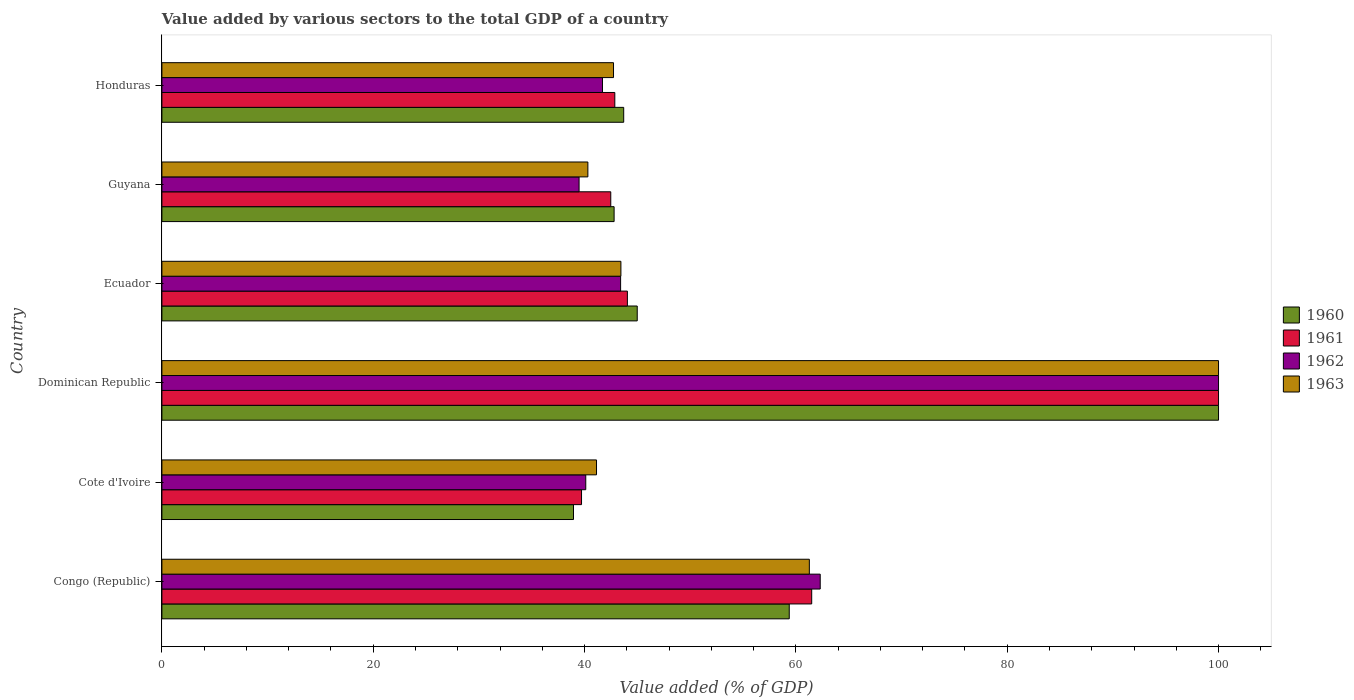Are the number of bars on each tick of the Y-axis equal?
Give a very brief answer. Yes. What is the label of the 4th group of bars from the top?
Provide a short and direct response. Dominican Republic. In how many cases, is the number of bars for a given country not equal to the number of legend labels?
Provide a succinct answer. 0. What is the value added by various sectors to the total GDP in 1963 in Congo (Republic)?
Offer a terse response. 61.27. Across all countries, what is the maximum value added by various sectors to the total GDP in 1960?
Your answer should be very brief. 100. Across all countries, what is the minimum value added by various sectors to the total GDP in 1963?
Your answer should be compact. 40.31. In which country was the value added by various sectors to the total GDP in 1963 maximum?
Keep it short and to the point. Dominican Republic. In which country was the value added by various sectors to the total GDP in 1961 minimum?
Provide a succinct answer. Cote d'Ivoire. What is the total value added by various sectors to the total GDP in 1962 in the graph?
Offer a very short reply. 327.01. What is the difference between the value added by various sectors to the total GDP in 1961 in Congo (Republic) and that in Guyana?
Give a very brief answer. 19.02. What is the difference between the value added by various sectors to the total GDP in 1962 in Dominican Republic and the value added by various sectors to the total GDP in 1960 in Cote d'Ivoire?
Your response must be concise. 61.05. What is the average value added by various sectors to the total GDP in 1960 per country?
Ensure brevity in your answer.  54.97. What is the difference between the value added by various sectors to the total GDP in 1961 and value added by various sectors to the total GDP in 1963 in Congo (Republic)?
Your answer should be compact. 0.22. What is the ratio of the value added by various sectors to the total GDP in 1962 in Congo (Republic) to that in Guyana?
Give a very brief answer. 1.58. Is the value added by various sectors to the total GDP in 1960 in Cote d'Ivoire less than that in Guyana?
Offer a terse response. Yes. What is the difference between the highest and the second highest value added by various sectors to the total GDP in 1963?
Offer a terse response. 38.73. What is the difference between the highest and the lowest value added by various sectors to the total GDP in 1963?
Provide a short and direct response. 59.69. Is the sum of the value added by various sectors to the total GDP in 1960 in Dominican Republic and Honduras greater than the maximum value added by various sectors to the total GDP in 1961 across all countries?
Keep it short and to the point. Yes. Is it the case that in every country, the sum of the value added by various sectors to the total GDP in 1960 and value added by various sectors to the total GDP in 1963 is greater than the sum of value added by various sectors to the total GDP in 1962 and value added by various sectors to the total GDP in 1961?
Offer a terse response. No. What does the 2nd bar from the top in Congo (Republic) represents?
Your answer should be very brief. 1962. How many bars are there?
Give a very brief answer. 24. Are all the bars in the graph horizontal?
Ensure brevity in your answer.  Yes. Are the values on the major ticks of X-axis written in scientific E-notation?
Provide a short and direct response. No. Does the graph contain grids?
Provide a succinct answer. No. How many legend labels are there?
Keep it short and to the point. 4. What is the title of the graph?
Offer a terse response. Value added by various sectors to the total GDP of a country. What is the label or title of the X-axis?
Keep it short and to the point. Value added (% of GDP). What is the Value added (% of GDP) of 1960 in Congo (Republic)?
Your answer should be compact. 59.37. What is the Value added (% of GDP) of 1961 in Congo (Republic)?
Offer a very short reply. 61.5. What is the Value added (% of GDP) of 1962 in Congo (Republic)?
Give a very brief answer. 62.3. What is the Value added (% of GDP) in 1963 in Congo (Republic)?
Keep it short and to the point. 61.27. What is the Value added (% of GDP) in 1960 in Cote d'Ivoire?
Offer a very short reply. 38.95. What is the Value added (% of GDP) in 1961 in Cote d'Ivoire?
Provide a succinct answer. 39.71. What is the Value added (% of GDP) of 1962 in Cote d'Ivoire?
Your response must be concise. 40.11. What is the Value added (% of GDP) in 1963 in Cote d'Ivoire?
Offer a terse response. 41.13. What is the Value added (% of GDP) in 1961 in Dominican Republic?
Your answer should be very brief. 100. What is the Value added (% of GDP) in 1962 in Dominican Republic?
Provide a short and direct response. 100. What is the Value added (% of GDP) in 1960 in Ecuador?
Provide a short and direct response. 44.99. What is the Value added (% of GDP) in 1961 in Ecuador?
Keep it short and to the point. 44.05. What is the Value added (% of GDP) in 1962 in Ecuador?
Ensure brevity in your answer.  43.41. What is the Value added (% of GDP) of 1963 in Ecuador?
Provide a short and direct response. 43.44. What is the Value added (% of GDP) of 1960 in Guyana?
Keep it short and to the point. 42.8. What is the Value added (% of GDP) of 1961 in Guyana?
Keep it short and to the point. 42.48. What is the Value added (% of GDP) in 1962 in Guyana?
Provide a short and direct response. 39.48. What is the Value added (% of GDP) of 1963 in Guyana?
Your answer should be very brief. 40.31. What is the Value added (% of GDP) in 1960 in Honduras?
Provide a short and direct response. 43.7. What is the Value added (% of GDP) in 1961 in Honduras?
Keep it short and to the point. 42.86. What is the Value added (% of GDP) in 1962 in Honduras?
Your response must be concise. 41.7. What is the Value added (% of GDP) in 1963 in Honduras?
Give a very brief answer. 42.74. Across all countries, what is the maximum Value added (% of GDP) in 1963?
Offer a very short reply. 100. Across all countries, what is the minimum Value added (% of GDP) of 1960?
Offer a terse response. 38.95. Across all countries, what is the minimum Value added (% of GDP) of 1961?
Your answer should be very brief. 39.71. Across all countries, what is the minimum Value added (% of GDP) of 1962?
Your response must be concise. 39.48. Across all countries, what is the minimum Value added (% of GDP) in 1963?
Your answer should be very brief. 40.31. What is the total Value added (% of GDP) of 1960 in the graph?
Your answer should be very brief. 329.81. What is the total Value added (% of GDP) in 1961 in the graph?
Ensure brevity in your answer.  330.61. What is the total Value added (% of GDP) of 1962 in the graph?
Offer a very short reply. 327.01. What is the total Value added (% of GDP) of 1963 in the graph?
Provide a succinct answer. 328.9. What is the difference between the Value added (% of GDP) in 1960 in Congo (Republic) and that in Cote d'Ivoire?
Your response must be concise. 20.42. What is the difference between the Value added (% of GDP) of 1961 in Congo (Republic) and that in Cote d'Ivoire?
Your answer should be very brief. 21.78. What is the difference between the Value added (% of GDP) in 1962 in Congo (Republic) and that in Cote d'Ivoire?
Provide a short and direct response. 22.19. What is the difference between the Value added (% of GDP) of 1963 in Congo (Republic) and that in Cote d'Ivoire?
Offer a very short reply. 20.14. What is the difference between the Value added (% of GDP) in 1960 in Congo (Republic) and that in Dominican Republic?
Ensure brevity in your answer.  -40.63. What is the difference between the Value added (% of GDP) of 1961 in Congo (Republic) and that in Dominican Republic?
Your answer should be very brief. -38.5. What is the difference between the Value added (% of GDP) in 1962 in Congo (Republic) and that in Dominican Republic?
Offer a terse response. -37.7. What is the difference between the Value added (% of GDP) of 1963 in Congo (Republic) and that in Dominican Republic?
Offer a very short reply. -38.73. What is the difference between the Value added (% of GDP) of 1960 in Congo (Republic) and that in Ecuador?
Give a very brief answer. 14.39. What is the difference between the Value added (% of GDP) of 1961 in Congo (Republic) and that in Ecuador?
Make the answer very short. 17.44. What is the difference between the Value added (% of GDP) of 1962 in Congo (Republic) and that in Ecuador?
Provide a succinct answer. 18.89. What is the difference between the Value added (% of GDP) in 1963 in Congo (Republic) and that in Ecuador?
Provide a short and direct response. 17.83. What is the difference between the Value added (% of GDP) in 1960 in Congo (Republic) and that in Guyana?
Keep it short and to the point. 16.57. What is the difference between the Value added (% of GDP) of 1961 in Congo (Republic) and that in Guyana?
Offer a very short reply. 19.02. What is the difference between the Value added (% of GDP) in 1962 in Congo (Republic) and that in Guyana?
Offer a very short reply. 22.82. What is the difference between the Value added (% of GDP) in 1963 in Congo (Republic) and that in Guyana?
Provide a succinct answer. 20.96. What is the difference between the Value added (% of GDP) of 1960 in Congo (Republic) and that in Honduras?
Your answer should be very brief. 15.67. What is the difference between the Value added (% of GDP) in 1961 in Congo (Republic) and that in Honduras?
Keep it short and to the point. 18.63. What is the difference between the Value added (% of GDP) in 1962 in Congo (Republic) and that in Honduras?
Your answer should be compact. 20.61. What is the difference between the Value added (% of GDP) of 1963 in Congo (Republic) and that in Honduras?
Ensure brevity in your answer.  18.53. What is the difference between the Value added (% of GDP) in 1960 in Cote d'Ivoire and that in Dominican Republic?
Your answer should be very brief. -61.05. What is the difference between the Value added (% of GDP) in 1961 in Cote d'Ivoire and that in Dominican Republic?
Your answer should be very brief. -60.29. What is the difference between the Value added (% of GDP) of 1962 in Cote d'Ivoire and that in Dominican Republic?
Offer a terse response. -59.89. What is the difference between the Value added (% of GDP) of 1963 in Cote d'Ivoire and that in Dominican Republic?
Your answer should be very brief. -58.87. What is the difference between the Value added (% of GDP) of 1960 in Cote d'Ivoire and that in Ecuador?
Your response must be concise. -6.03. What is the difference between the Value added (% of GDP) of 1961 in Cote d'Ivoire and that in Ecuador?
Keep it short and to the point. -4.34. What is the difference between the Value added (% of GDP) of 1962 in Cote d'Ivoire and that in Ecuador?
Offer a terse response. -3.3. What is the difference between the Value added (% of GDP) in 1963 in Cote d'Ivoire and that in Ecuador?
Give a very brief answer. -2.31. What is the difference between the Value added (% of GDP) of 1960 in Cote d'Ivoire and that in Guyana?
Provide a succinct answer. -3.84. What is the difference between the Value added (% of GDP) in 1961 in Cote d'Ivoire and that in Guyana?
Offer a terse response. -2.77. What is the difference between the Value added (% of GDP) of 1962 in Cote d'Ivoire and that in Guyana?
Offer a terse response. 0.63. What is the difference between the Value added (% of GDP) in 1963 in Cote d'Ivoire and that in Guyana?
Your answer should be very brief. 0.82. What is the difference between the Value added (% of GDP) in 1960 in Cote d'Ivoire and that in Honduras?
Make the answer very short. -4.75. What is the difference between the Value added (% of GDP) of 1961 in Cote d'Ivoire and that in Honduras?
Keep it short and to the point. -3.15. What is the difference between the Value added (% of GDP) of 1962 in Cote d'Ivoire and that in Honduras?
Provide a succinct answer. -1.58. What is the difference between the Value added (% of GDP) in 1963 in Cote d'Ivoire and that in Honduras?
Your response must be concise. -1.61. What is the difference between the Value added (% of GDP) in 1960 in Dominican Republic and that in Ecuador?
Offer a terse response. 55.02. What is the difference between the Value added (% of GDP) of 1961 in Dominican Republic and that in Ecuador?
Your answer should be compact. 55.95. What is the difference between the Value added (% of GDP) in 1962 in Dominican Republic and that in Ecuador?
Your response must be concise. 56.59. What is the difference between the Value added (% of GDP) in 1963 in Dominican Republic and that in Ecuador?
Offer a terse response. 56.56. What is the difference between the Value added (% of GDP) in 1960 in Dominican Republic and that in Guyana?
Provide a short and direct response. 57.2. What is the difference between the Value added (% of GDP) in 1961 in Dominican Republic and that in Guyana?
Offer a terse response. 57.52. What is the difference between the Value added (% of GDP) of 1962 in Dominican Republic and that in Guyana?
Ensure brevity in your answer.  60.52. What is the difference between the Value added (% of GDP) in 1963 in Dominican Republic and that in Guyana?
Your response must be concise. 59.69. What is the difference between the Value added (% of GDP) of 1960 in Dominican Republic and that in Honduras?
Provide a short and direct response. 56.3. What is the difference between the Value added (% of GDP) in 1961 in Dominican Republic and that in Honduras?
Keep it short and to the point. 57.14. What is the difference between the Value added (% of GDP) of 1962 in Dominican Republic and that in Honduras?
Your answer should be very brief. 58.3. What is the difference between the Value added (% of GDP) in 1963 in Dominican Republic and that in Honduras?
Offer a very short reply. 57.26. What is the difference between the Value added (% of GDP) of 1960 in Ecuador and that in Guyana?
Ensure brevity in your answer.  2.19. What is the difference between the Value added (% of GDP) of 1961 in Ecuador and that in Guyana?
Your answer should be compact. 1.57. What is the difference between the Value added (% of GDP) in 1962 in Ecuador and that in Guyana?
Your response must be concise. 3.93. What is the difference between the Value added (% of GDP) of 1963 in Ecuador and that in Guyana?
Your response must be concise. 3.13. What is the difference between the Value added (% of GDP) in 1960 in Ecuador and that in Honduras?
Offer a terse response. 1.28. What is the difference between the Value added (% of GDP) in 1961 in Ecuador and that in Honduras?
Your answer should be very brief. 1.19. What is the difference between the Value added (% of GDP) in 1962 in Ecuador and that in Honduras?
Ensure brevity in your answer.  1.72. What is the difference between the Value added (% of GDP) in 1963 in Ecuador and that in Honduras?
Your response must be concise. 0.7. What is the difference between the Value added (% of GDP) of 1960 in Guyana and that in Honduras?
Your answer should be very brief. -0.91. What is the difference between the Value added (% of GDP) in 1961 in Guyana and that in Honduras?
Your answer should be very brief. -0.38. What is the difference between the Value added (% of GDP) of 1962 in Guyana and that in Honduras?
Your answer should be very brief. -2.21. What is the difference between the Value added (% of GDP) in 1963 in Guyana and that in Honduras?
Offer a terse response. -2.43. What is the difference between the Value added (% of GDP) of 1960 in Congo (Republic) and the Value added (% of GDP) of 1961 in Cote d'Ivoire?
Offer a very short reply. 19.66. What is the difference between the Value added (% of GDP) of 1960 in Congo (Republic) and the Value added (% of GDP) of 1962 in Cote d'Ivoire?
Keep it short and to the point. 19.26. What is the difference between the Value added (% of GDP) in 1960 in Congo (Republic) and the Value added (% of GDP) in 1963 in Cote d'Ivoire?
Offer a very short reply. 18.24. What is the difference between the Value added (% of GDP) in 1961 in Congo (Republic) and the Value added (% of GDP) in 1962 in Cote d'Ivoire?
Provide a short and direct response. 21.38. What is the difference between the Value added (% of GDP) of 1961 in Congo (Republic) and the Value added (% of GDP) of 1963 in Cote d'Ivoire?
Your response must be concise. 20.36. What is the difference between the Value added (% of GDP) in 1962 in Congo (Republic) and the Value added (% of GDP) in 1963 in Cote d'Ivoire?
Your answer should be very brief. 21.17. What is the difference between the Value added (% of GDP) of 1960 in Congo (Republic) and the Value added (% of GDP) of 1961 in Dominican Republic?
Provide a succinct answer. -40.63. What is the difference between the Value added (% of GDP) in 1960 in Congo (Republic) and the Value added (% of GDP) in 1962 in Dominican Republic?
Give a very brief answer. -40.63. What is the difference between the Value added (% of GDP) in 1960 in Congo (Republic) and the Value added (% of GDP) in 1963 in Dominican Republic?
Your answer should be compact. -40.63. What is the difference between the Value added (% of GDP) of 1961 in Congo (Republic) and the Value added (% of GDP) of 1962 in Dominican Republic?
Give a very brief answer. -38.5. What is the difference between the Value added (% of GDP) of 1961 in Congo (Republic) and the Value added (% of GDP) of 1963 in Dominican Republic?
Offer a terse response. -38.5. What is the difference between the Value added (% of GDP) of 1962 in Congo (Republic) and the Value added (% of GDP) of 1963 in Dominican Republic?
Offer a terse response. -37.7. What is the difference between the Value added (% of GDP) of 1960 in Congo (Republic) and the Value added (% of GDP) of 1961 in Ecuador?
Your answer should be compact. 15.32. What is the difference between the Value added (% of GDP) of 1960 in Congo (Republic) and the Value added (% of GDP) of 1962 in Ecuador?
Ensure brevity in your answer.  15.96. What is the difference between the Value added (% of GDP) of 1960 in Congo (Republic) and the Value added (% of GDP) of 1963 in Ecuador?
Offer a very short reply. 15.93. What is the difference between the Value added (% of GDP) of 1961 in Congo (Republic) and the Value added (% of GDP) of 1962 in Ecuador?
Make the answer very short. 18.08. What is the difference between the Value added (% of GDP) in 1961 in Congo (Republic) and the Value added (% of GDP) in 1963 in Ecuador?
Offer a terse response. 18.06. What is the difference between the Value added (% of GDP) of 1962 in Congo (Republic) and the Value added (% of GDP) of 1963 in Ecuador?
Provide a succinct answer. 18.86. What is the difference between the Value added (% of GDP) of 1960 in Congo (Republic) and the Value added (% of GDP) of 1961 in Guyana?
Give a very brief answer. 16.89. What is the difference between the Value added (% of GDP) in 1960 in Congo (Republic) and the Value added (% of GDP) in 1962 in Guyana?
Offer a terse response. 19.89. What is the difference between the Value added (% of GDP) in 1960 in Congo (Republic) and the Value added (% of GDP) in 1963 in Guyana?
Your answer should be compact. 19.06. What is the difference between the Value added (% of GDP) in 1961 in Congo (Republic) and the Value added (% of GDP) in 1962 in Guyana?
Offer a very short reply. 22.02. What is the difference between the Value added (% of GDP) of 1961 in Congo (Republic) and the Value added (% of GDP) of 1963 in Guyana?
Keep it short and to the point. 21.18. What is the difference between the Value added (% of GDP) in 1962 in Congo (Republic) and the Value added (% of GDP) in 1963 in Guyana?
Offer a terse response. 21.99. What is the difference between the Value added (% of GDP) in 1960 in Congo (Republic) and the Value added (% of GDP) in 1961 in Honduras?
Offer a terse response. 16.51. What is the difference between the Value added (% of GDP) in 1960 in Congo (Republic) and the Value added (% of GDP) in 1962 in Honduras?
Offer a terse response. 17.67. What is the difference between the Value added (% of GDP) in 1960 in Congo (Republic) and the Value added (% of GDP) in 1963 in Honduras?
Provide a short and direct response. 16.63. What is the difference between the Value added (% of GDP) in 1961 in Congo (Republic) and the Value added (% of GDP) in 1962 in Honduras?
Your response must be concise. 19.8. What is the difference between the Value added (% of GDP) in 1961 in Congo (Republic) and the Value added (% of GDP) in 1963 in Honduras?
Your response must be concise. 18.76. What is the difference between the Value added (% of GDP) of 1962 in Congo (Republic) and the Value added (% of GDP) of 1963 in Honduras?
Your answer should be very brief. 19.56. What is the difference between the Value added (% of GDP) in 1960 in Cote d'Ivoire and the Value added (% of GDP) in 1961 in Dominican Republic?
Keep it short and to the point. -61.05. What is the difference between the Value added (% of GDP) in 1960 in Cote d'Ivoire and the Value added (% of GDP) in 1962 in Dominican Republic?
Keep it short and to the point. -61.05. What is the difference between the Value added (% of GDP) in 1960 in Cote d'Ivoire and the Value added (% of GDP) in 1963 in Dominican Republic?
Give a very brief answer. -61.05. What is the difference between the Value added (% of GDP) of 1961 in Cote d'Ivoire and the Value added (% of GDP) of 1962 in Dominican Republic?
Give a very brief answer. -60.29. What is the difference between the Value added (% of GDP) in 1961 in Cote d'Ivoire and the Value added (% of GDP) in 1963 in Dominican Republic?
Provide a short and direct response. -60.29. What is the difference between the Value added (% of GDP) of 1962 in Cote d'Ivoire and the Value added (% of GDP) of 1963 in Dominican Republic?
Give a very brief answer. -59.89. What is the difference between the Value added (% of GDP) in 1960 in Cote d'Ivoire and the Value added (% of GDP) in 1961 in Ecuador?
Keep it short and to the point. -5.1. What is the difference between the Value added (% of GDP) in 1960 in Cote d'Ivoire and the Value added (% of GDP) in 1962 in Ecuador?
Offer a very short reply. -4.46. What is the difference between the Value added (% of GDP) of 1960 in Cote d'Ivoire and the Value added (% of GDP) of 1963 in Ecuador?
Provide a succinct answer. -4.49. What is the difference between the Value added (% of GDP) of 1961 in Cote d'Ivoire and the Value added (% of GDP) of 1962 in Ecuador?
Keep it short and to the point. -3.7. What is the difference between the Value added (% of GDP) of 1961 in Cote d'Ivoire and the Value added (% of GDP) of 1963 in Ecuador?
Ensure brevity in your answer.  -3.73. What is the difference between the Value added (% of GDP) of 1962 in Cote d'Ivoire and the Value added (% of GDP) of 1963 in Ecuador?
Provide a short and direct response. -3.33. What is the difference between the Value added (% of GDP) of 1960 in Cote d'Ivoire and the Value added (% of GDP) of 1961 in Guyana?
Offer a very short reply. -3.53. What is the difference between the Value added (% of GDP) of 1960 in Cote d'Ivoire and the Value added (% of GDP) of 1962 in Guyana?
Offer a very short reply. -0.53. What is the difference between the Value added (% of GDP) of 1960 in Cote d'Ivoire and the Value added (% of GDP) of 1963 in Guyana?
Your answer should be compact. -1.36. What is the difference between the Value added (% of GDP) of 1961 in Cote d'Ivoire and the Value added (% of GDP) of 1962 in Guyana?
Your answer should be very brief. 0.23. What is the difference between the Value added (% of GDP) of 1961 in Cote d'Ivoire and the Value added (% of GDP) of 1963 in Guyana?
Make the answer very short. -0.6. What is the difference between the Value added (% of GDP) in 1962 in Cote d'Ivoire and the Value added (% of GDP) in 1963 in Guyana?
Provide a short and direct response. -0.2. What is the difference between the Value added (% of GDP) of 1960 in Cote d'Ivoire and the Value added (% of GDP) of 1961 in Honduras?
Your answer should be compact. -3.91. What is the difference between the Value added (% of GDP) in 1960 in Cote d'Ivoire and the Value added (% of GDP) in 1962 in Honduras?
Provide a succinct answer. -2.74. What is the difference between the Value added (% of GDP) in 1960 in Cote d'Ivoire and the Value added (% of GDP) in 1963 in Honduras?
Offer a very short reply. -3.79. What is the difference between the Value added (% of GDP) in 1961 in Cote d'Ivoire and the Value added (% of GDP) in 1962 in Honduras?
Keep it short and to the point. -1.98. What is the difference between the Value added (% of GDP) in 1961 in Cote d'Ivoire and the Value added (% of GDP) in 1963 in Honduras?
Keep it short and to the point. -3.03. What is the difference between the Value added (% of GDP) in 1962 in Cote d'Ivoire and the Value added (% of GDP) in 1963 in Honduras?
Your answer should be very brief. -2.63. What is the difference between the Value added (% of GDP) in 1960 in Dominican Republic and the Value added (% of GDP) in 1961 in Ecuador?
Offer a terse response. 55.95. What is the difference between the Value added (% of GDP) of 1960 in Dominican Republic and the Value added (% of GDP) of 1962 in Ecuador?
Your answer should be compact. 56.59. What is the difference between the Value added (% of GDP) of 1960 in Dominican Republic and the Value added (% of GDP) of 1963 in Ecuador?
Give a very brief answer. 56.56. What is the difference between the Value added (% of GDP) of 1961 in Dominican Republic and the Value added (% of GDP) of 1962 in Ecuador?
Your response must be concise. 56.59. What is the difference between the Value added (% of GDP) of 1961 in Dominican Republic and the Value added (% of GDP) of 1963 in Ecuador?
Your response must be concise. 56.56. What is the difference between the Value added (% of GDP) in 1962 in Dominican Republic and the Value added (% of GDP) in 1963 in Ecuador?
Your response must be concise. 56.56. What is the difference between the Value added (% of GDP) of 1960 in Dominican Republic and the Value added (% of GDP) of 1961 in Guyana?
Make the answer very short. 57.52. What is the difference between the Value added (% of GDP) of 1960 in Dominican Republic and the Value added (% of GDP) of 1962 in Guyana?
Ensure brevity in your answer.  60.52. What is the difference between the Value added (% of GDP) of 1960 in Dominican Republic and the Value added (% of GDP) of 1963 in Guyana?
Your answer should be compact. 59.69. What is the difference between the Value added (% of GDP) in 1961 in Dominican Republic and the Value added (% of GDP) in 1962 in Guyana?
Provide a short and direct response. 60.52. What is the difference between the Value added (% of GDP) of 1961 in Dominican Republic and the Value added (% of GDP) of 1963 in Guyana?
Make the answer very short. 59.69. What is the difference between the Value added (% of GDP) in 1962 in Dominican Republic and the Value added (% of GDP) in 1963 in Guyana?
Offer a terse response. 59.69. What is the difference between the Value added (% of GDP) in 1960 in Dominican Republic and the Value added (% of GDP) in 1961 in Honduras?
Offer a terse response. 57.14. What is the difference between the Value added (% of GDP) in 1960 in Dominican Republic and the Value added (% of GDP) in 1962 in Honduras?
Make the answer very short. 58.3. What is the difference between the Value added (% of GDP) in 1960 in Dominican Republic and the Value added (% of GDP) in 1963 in Honduras?
Offer a terse response. 57.26. What is the difference between the Value added (% of GDP) in 1961 in Dominican Republic and the Value added (% of GDP) in 1962 in Honduras?
Give a very brief answer. 58.3. What is the difference between the Value added (% of GDP) in 1961 in Dominican Republic and the Value added (% of GDP) in 1963 in Honduras?
Make the answer very short. 57.26. What is the difference between the Value added (% of GDP) in 1962 in Dominican Republic and the Value added (% of GDP) in 1963 in Honduras?
Keep it short and to the point. 57.26. What is the difference between the Value added (% of GDP) of 1960 in Ecuador and the Value added (% of GDP) of 1961 in Guyana?
Make the answer very short. 2.5. What is the difference between the Value added (% of GDP) in 1960 in Ecuador and the Value added (% of GDP) in 1962 in Guyana?
Ensure brevity in your answer.  5.5. What is the difference between the Value added (% of GDP) in 1960 in Ecuador and the Value added (% of GDP) in 1963 in Guyana?
Offer a terse response. 4.67. What is the difference between the Value added (% of GDP) in 1961 in Ecuador and the Value added (% of GDP) in 1962 in Guyana?
Provide a short and direct response. 4.57. What is the difference between the Value added (% of GDP) in 1961 in Ecuador and the Value added (% of GDP) in 1963 in Guyana?
Your answer should be very brief. 3.74. What is the difference between the Value added (% of GDP) in 1962 in Ecuador and the Value added (% of GDP) in 1963 in Guyana?
Make the answer very short. 3.1. What is the difference between the Value added (% of GDP) of 1960 in Ecuador and the Value added (% of GDP) of 1961 in Honduras?
Make the answer very short. 2.12. What is the difference between the Value added (% of GDP) of 1960 in Ecuador and the Value added (% of GDP) of 1962 in Honduras?
Your answer should be very brief. 3.29. What is the difference between the Value added (% of GDP) of 1960 in Ecuador and the Value added (% of GDP) of 1963 in Honduras?
Make the answer very short. 2.24. What is the difference between the Value added (% of GDP) of 1961 in Ecuador and the Value added (% of GDP) of 1962 in Honduras?
Offer a very short reply. 2.36. What is the difference between the Value added (% of GDP) in 1961 in Ecuador and the Value added (% of GDP) in 1963 in Honduras?
Your answer should be compact. 1.31. What is the difference between the Value added (% of GDP) in 1962 in Ecuador and the Value added (% of GDP) in 1963 in Honduras?
Ensure brevity in your answer.  0.67. What is the difference between the Value added (% of GDP) in 1960 in Guyana and the Value added (% of GDP) in 1961 in Honduras?
Offer a very short reply. -0.07. What is the difference between the Value added (% of GDP) in 1960 in Guyana and the Value added (% of GDP) in 1963 in Honduras?
Offer a terse response. 0.06. What is the difference between the Value added (% of GDP) in 1961 in Guyana and the Value added (% of GDP) in 1962 in Honduras?
Give a very brief answer. 0.78. What is the difference between the Value added (% of GDP) in 1961 in Guyana and the Value added (% of GDP) in 1963 in Honduras?
Offer a terse response. -0.26. What is the difference between the Value added (% of GDP) of 1962 in Guyana and the Value added (% of GDP) of 1963 in Honduras?
Ensure brevity in your answer.  -3.26. What is the average Value added (% of GDP) in 1960 per country?
Give a very brief answer. 54.97. What is the average Value added (% of GDP) of 1961 per country?
Make the answer very short. 55.1. What is the average Value added (% of GDP) in 1962 per country?
Provide a succinct answer. 54.5. What is the average Value added (% of GDP) of 1963 per country?
Offer a terse response. 54.82. What is the difference between the Value added (% of GDP) in 1960 and Value added (% of GDP) in 1961 in Congo (Republic)?
Make the answer very short. -2.13. What is the difference between the Value added (% of GDP) of 1960 and Value added (% of GDP) of 1962 in Congo (Republic)?
Make the answer very short. -2.93. What is the difference between the Value added (% of GDP) in 1960 and Value added (% of GDP) in 1963 in Congo (Republic)?
Make the answer very short. -1.9. What is the difference between the Value added (% of GDP) in 1961 and Value added (% of GDP) in 1962 in Congo (Republic)?
Your response must be concise. -0.81. What is the difference between the Value added (% of GDP) of 1961 and Value added (% of GDP) of 1963 in Congo (Republic)?
Your answer should be very brief. 0.22. What is the difference between the Value added (% of GDP) of 1962 and Value added (% of GDP) of 1963 in Congo (Republic)?
Make the answer very short. 1.03. What is the difference between the Value added (% of GDP) of 1960 and Value added (% of GDP) of 1961 in Cote d'Ivoire?
Offer a very short reply. -0.76. What is the difference between the Value added (% of GDP) in 1960 and Value added (% of GDP) in 1962 in Cote d'Ivoire?
Your answer should be compact. -1.16. What is the difference between the Value added (% of GDP) of 1960 and Value added (% of GDP) of 1963 in Cote d'Ivoire?
Offer a very short reply. -2.18. What is the difference between the Value added (% of GDP) in 1961 and Value added (% of GDP) in 1962 in Cote d'Ivoire?
Give a very brief answer. -0.4. What is the difference between the Value added (% of GDP) in 1961 and Value added (% of GDP) in 1963 in Cote d'Ivoire?
Your answer should be very brief. -1.42. What is the difference between the Value added (% of GDP) of 1962 and Value added (% of GDP) of 1963 in Cote d'Ivoire?
Offer a terse response. -1.02. What is the difference between the Value added (% of GDP) in 1960 and Value added (% of GDP) in 1961 in Dominican Republic?
Give a very brief answer. 0. What is the difference between the Value added (% of GDP) in 1960 and Value added (% of GDP) in 1963 in Dominican Republic?
Provide a succinct answer. 0. What is the difference between the Value added (% of GDP) in 1961 and Value added (% of GDP) in 1962 in Dominican Republic?
Provide a succinct answer. 0. What is the difference between the Value added (% of GDP) in 1962 and Value added (% of GDP) in 1963 in Dominican Republic?
Keep it short and to the point. 0. What is the difference between the Value added (% of GDP) in 1960 and Value added (% of GDP) in 1961 in Ecuador?
Give a very brief answer. 0.93. What is the difference between the Value added (% of GDP) of 1960 and Value added (% of GDP) of 1962 in Ecuador?
Your answer should be compact. 1.57. What is the difference between the Value added (% of GDP) of 1960 and Value added (% of GDP) of 1963 in Ecuador?
Give a very brief answer. 1.54. What is the difference between the Value added (% of GDP) in 1961 and Value added (% of GDP) in 1962 in Ecuador?
Keep it short and to the point. 0.64. What is the difference between the Value added (% of GDP) in 1961 and Value added (% of GDP) in 1963 in Ecuador?
Provide a short and direct response. 0.61. What is the difference between the Value added (% of GDP) in 1962 and Value added (% of GDP) in 1963 in Ecuador?
Offer a terse response. -0.03. What is the difference between the Value added (% of GDP) of 1960 and Value added (% of GDP) of 1961 in Guyana?
Your answer should be very brief. 0.32. What is the difference between the Value added (% of GDP) of 1960 and Value added (% of GDP) of 1962 in Guyana?
Keep it short and to the point. 3.31. What is the difference between the Value added (% of GDP) of 1960 and Value added (% of GDP) of 1963 in Guyana?
Provide a short and direct response. 2.48. What is the difference between the Value added (% of GDP) of 1961 and Value added (% of GDP) of 1962 in Guyana?
Make the answer very short. 3. What is the difference between the Value added (% of GDP) in 1961 and Value added (% of GDP) in 1963 in Guyana?
Provide a succinct answer. 2.17. What is the difference between the Value added (% of GDP) in 1962 and Value added (% of GDP) in 1963 in Guyana?
Keep it short and to the point. -0.83. What is the difference between the Value added (% of GDP) of 1960 and Value added (% of GDP) of 1961 in Honduras?
Keep it short and to the point. 0.84. What is the difference between the Value added (% of GDP) of 1960 and Value added (% of GDP) of 1962 in Honduras?
Make the answer very short. 2.01. What is the difference between the Value added (% of GDP) in 1960 and Value added (% of GDP) in 1963 in Honduras?
Your answer should be compact. 0.96. What is the difference between the Value added (% of GDP) of 1961 and Value added (% of GDP) of 1962 in Honduras?
Your answer should be compact. 1.17. What is the difference between the Value added (% of GDP) in 1961 and Value added (% of GDP) in 1963 in Honduras?
Provide a succinct answer. 0.12. What is the difference between the Value added (% of GDP) in 1962 and Value added (% of GDP) in 1963 in Honduras?
Your response must be concise. -1.04. What is the ratio of the Value added (% of GDP) in 1960 in Congo (Republic) to that in Cote d'Ivoire?
Keep it short and to the point. 1.52. What is the ratio of the Value added (% of GDP) of 1961 in Congo (Republic) to that in Cote d'Ivoire?
Provide a succinct answer. 1.55. What is the ratio of the Value added (% of GDP) in 1962 in Congo (Republic) to that in Cote d'Ivoire?
Provide a succinct answer. 1.55. What is the ratio of the Value added (% of GDP) of 1963 in Congo (Republic) to that in Cote d'Ivoire?
Give a very brief answer. 1.49. What is the ratio of the Value added (% of GDP) of 1960 in Congo (Republic) to that in Dominican Republic?
Your answer should be very brief. 0.59. What is the ratio of the Value added (% of GDP) of 1961 in Congo (Republic) to that in Dominican Republic?
Offer a very short reply. 0.61. What is the ratio of the Value added (% of GDP) of 1962 in Congo (Republic) to that in Dominican Republic?
Provide a short and direct response. 0.62. What is the ratio of the Value added (% of GDP) of 1963 in Congo (Republic) to that in Dominican Republic?
Provide a succinct answer. 0.61. What is the ratio of the Value added (% of GDP) of 1960 in Congo (Republic) to that in Ecuador?
Provide a succinct answer. 1.32. What is the ratio of the Value added (% of GDP) in 1961 in Congo (Republic) to that in Ecuador?
Ensure brevity in your answer.  1.4. What is the ratio of the Value added (% of GDP) in 1962 in Congo (Republic) to that in Ecuador?
Give a very brief answer. 1.44. What is the ratio of the Value added (% of GDP) of 1963 in Congo (Republic) to that in Ecuador?
Offer a very short reply. 1.41. What is the ratio of the Value added (% of GDP) of 1960 in Congo (Republic) to that in Guyana?
Ensure brevity in your answer.  1.39. What is the ratio of the Value added (% of GDP) of 1961 in Congo (Republic) to that in Guyana?
Make the answer very short. 1.45. What is the ratio of the Value added (% of GDP) of 1962 in Congo (Republic) to that in Guyana?
Your response must be concise. 1.58. What is the ratio of the Value added (% of GDP) of 1963 in Congo (Republic) to that in Guyana?
Your response must be concise. 1.52. What is the ratio of the Value added (% of GDP) in 1960 in Congo (Republic) to that in Honduras?
Provide a succinct answer. 1.36. What is the ratio of the Value added (% of GDP) in 1961 in Congo (Republic) to that in Honduras?
Your answer should be compact. 1.43. What is the ratio of the Value added (% of GDP) of 1962 in Congo (Republic) to that in Honduras?
Your answer should be very brief. 1.49. What is the ratio of the Value added (% of GDP) of 1963 in Congo (Republic) to that in Honduras?
Offer a terse response. 1.43. What is the ratio of the Value added (% of GDP) of 1960 in Cote d'Ivoire to that in Dominican Republic?
Your answer should be compact. 0.39. What is the ratio of the Value added (% of GDP) of 1961 in Cote d'Ivoire to that in Dominican Republic?
Give a very brief answer. 0.4. What is the ratio of the Value added (% of GDP) in 1962 in Cote d'Ivoire to that in Dominican Republic?
Provide a short and direct response. 0.4. What is the ratio of the Value added (% of GDP) in 1963 in Cote d'Ivoire to that in Dominican Republic?
Ensure brevity in your answer.  0.41. What is the ratio of the Value added (% of GDP) in 1960 in Cote d'Ivoire to that in Ecuador?
Make the answer very short. 0.87. What is the ratio of the Value added (% of GDP) in 1961 in Cote d'Ivoire to that in Ecuador?
Make the answer very short. 0.9. What is the ratio of the Value added (% of GDP) in 1962 in Cote d'Ivoire to that in Ecuador?
Your response must be concise. 0.92. What is the ratio of the Value added (% of GDP) in 1963 in Cote d'Ivoire to that in Ecuador?
Make the answer very short. 0.95. What is the ratio of the Value added (% of GDP) in 1960 in Cote d'Ivoire to that in Guyana?
Ensure brevity in your answer.  0.91. What is the ratio of the Value added (% of GDP) of 1961 in Cote d'Ivoire to that in Guyana?
Your answer should be very brief. 0.93. What is the ratio of the Value added (% of GDP) of 1962 in Cote d'Ivoire to that in Guyana?
Your answer should be very brief. 1.02. What is the ratio of the Value added (% of GDP) of 1963 in Cote d'Ivoire to that in Guyana?
Give a very brief answer. 1.02. What is the ratio of the Value added (% of GDP) in 1960 in Cote d'Ivoire to that in Honduras?
Ensure brevity in your answer.  0.89. What is the ratio of the Value added (% of GDP) of 1961 in Cote d'Ivoire to that in Honduras?
Your answer should be compact. 0.93. What is the ratio of the Value added (% of GDP) of 1962 in Cote d'Ivoire to that in Honduras?
Your response must be concise. 0.96. What is the ratio of the Value added (% of GDP) of 1963 in Cote d'Ivoire to that in Honduras?
Make the answer very short. 0.96. What is the ratio of the Value added (% of GDP) in 1960 in Dominican Republic to that in Ecuador?
Your answer should be very brief. 2.22. What is the ratio of the Value added (% of GDP) in 1961 in Dominican Republic to that in Ecuador?
Offer a very short reply. 2.27. What is the ratio of the Value added (% of GDP) in 1962 in Dominican Republic to that in Ecuador?
Provide a succinct answer. 2.3. What is the ratio of the Value added (% of GDP) in 1963 in Dominican Republic to that in Ecuador?
Your response must be concise. 2.3. What is the ratio of the Value added (% of GDP) in 1960 in Dominican Republic to that in Guyana?
Your answer should be compact. 2.34. What is the ratio of the Value added (% of GDP) in 1961 in Dominican Republic to that in Guyana?
Your answer should be compact. 2.35. What is the ratio of the Value added (% of GDP) in 1962 in Dominican Republic to that in Guyana?
Your answer should be very brief. 2.53. What is the ratio of the Value added (% of GDP) of 1963 in Dominican Republic to that in Guyana?
Give a very brief answer. 2.48. What is the ratio of the Value added (% of GDP) of 1960 in Dominican Republic to that in Honduras?
Keep it short and to the point. 2.29. What is the ratio of the Value added (% of GDP) in 1961 in Dominican Republic to that in Honduras?
Give a very brief answer. 2.33. What is the ratio of the Value added (% of GDP) in 1962 in Dominican Republic to that in Honduras?
Your answer should be very brief. 2.4. What is the ratio of the Value added (% of GDP) in 1963 in Dominican Republic to that in Honduras?
Provide a short and direct response. 2.34. What is the ratio of the Value added (% of GDP) in 1960 in Ecuador to that in Guyana?
Provide a short and direct response. 1.05. What is the ratio of the Value added (% of GDP) of 1962 in Ecuador to that in Guyana?
Keep it short and to the point. 1.1. What is the ratio of the Value added (% of GDP) of 1963 in Ecuador to that in Guyana?
Your response must be concise. 1.08. What is the ratio of the Value added (% of GDP) of 1960 in Ecuador to that in Honduras?
Offer a terse response. 1.03. What is the ratio of the Value added (% of GDP) of 1961 in Ecuador to that in Honduras?
Keep it short and to the point. 1.03. What is the ratio of the Value added (% of GDP) in 1962 in Ecuador to that in Honduras?
Offer a terse response. 1.04. What is the ratio of the Value added (% of GDP) in 1963 in Ecuador to that in Honduras?
Provide a short and direct response. 1.02. What is the ratio of the Value added (% of GDP) in 1960 in Guyana to that in Honduras?
Make the answer very short. 0.98. What is the ratio of the Value added (% of GDP) of 1962 in Guyana to that in Honduras?
Offer a terse response. 0.95. What is the ratio of the Value added (% of GDP) in 1963 in Guyana to that in Honduras?
Provide a short and direct response. 0.94. What is the difference between the highest and the second highest Value added (% of GDP) in 1960?
Offer a terse response. 40.63. What is the difference between the highest and the second highest Value added (% of GDP) in 1961?
Ensure brevity in your answer.  38.5. What is the difference between the highest and the second highest Value added (% of GDP) in 1962?
Provide a succinct answer. 37.7. What is the difference between the highest and the second highest Value added (% of GDP) in 1963?
Your answer should be very brief. 38.73. What is the difference between the highest and the lowest Value added (% of GDP) of 1960?
Make the answer very short. 61.05. What is the difference between the highest and the lowest Value added (% of GDP) in 1961?
Offer a terse response. 60.29. What is the difference between the highest and the lowest Value added (% of GDP) in 1962?
Offer a terse response. 60.52. What is the difference between the highest and the lowest Value added (% of GDP) of 1963?
Give a very brief answer. 59.69. 